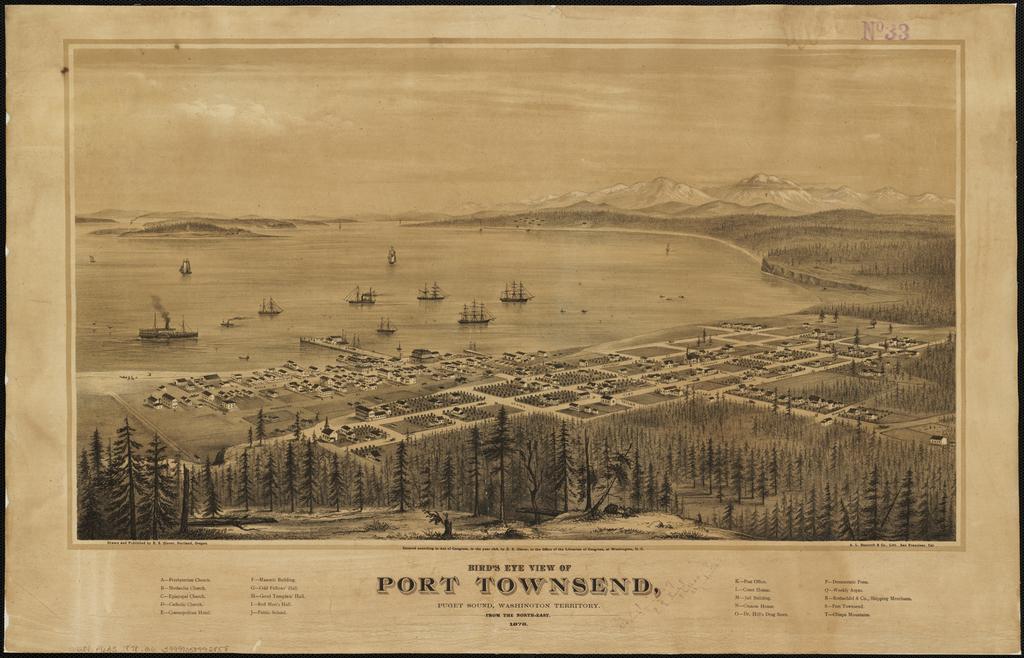What's the name of the port?
Make the answer very short. Port townsend. What is written under the town name?
Make the answer very short. Puget sound, washington territory. 